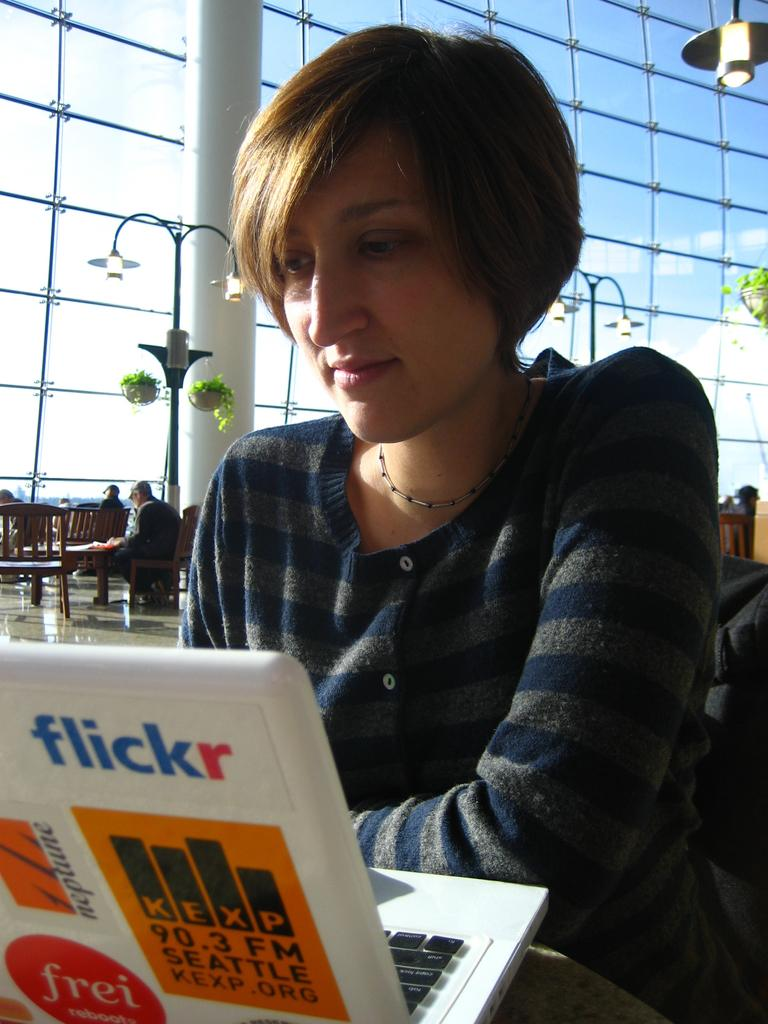Who is the main subject in the image? There is a woman in the image. What is the woman doing in the image? The woman is looking at a laptop. What can be seen in the background of the image? There are benches in the background of the image. What type of hot beverage is the woman holding in the image? There is no hot beverage visible in the image; the woman is looking at a laptop. 